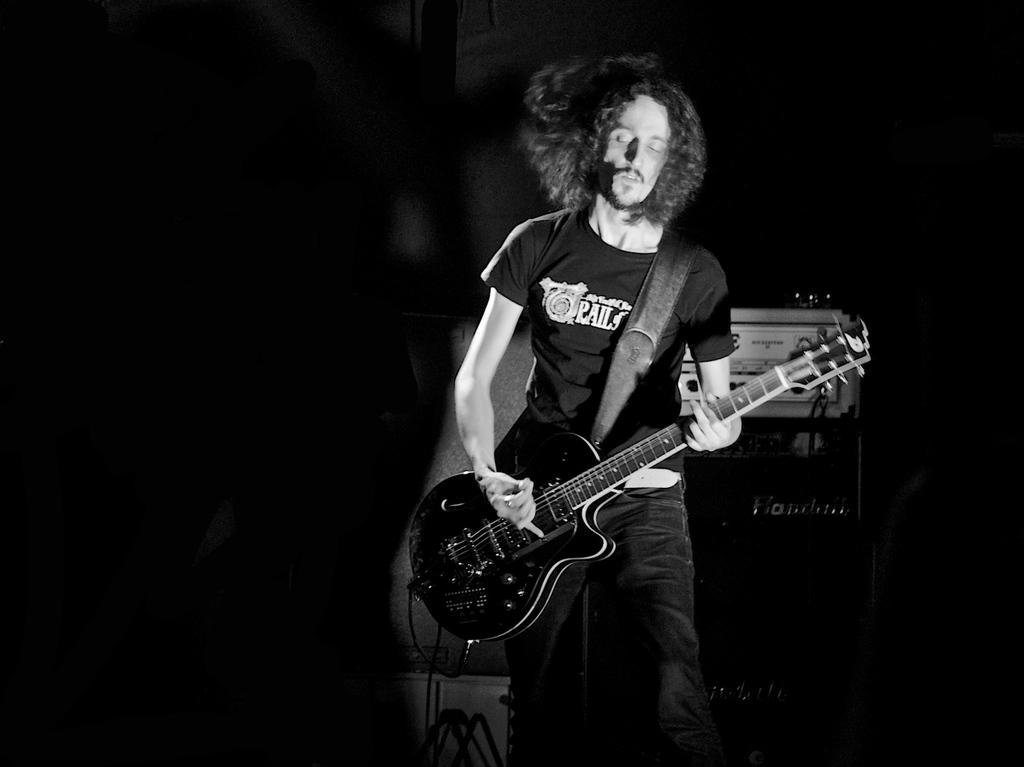What is the man in the image doing? The man is holding a guitar with his left hand and playing it with his right hand. What object is the man holding in the image? The man is holding a guitar in the image. What can be seen in the background of the image? There is equipment and cables in the background of the image. What type of destruction is the man causing in the image? There is no destruction present in the image; the man is simply playing a guitar. What cast member from a popular TV show is present in the image? There is no information about any cast members from TV shows in the image. 